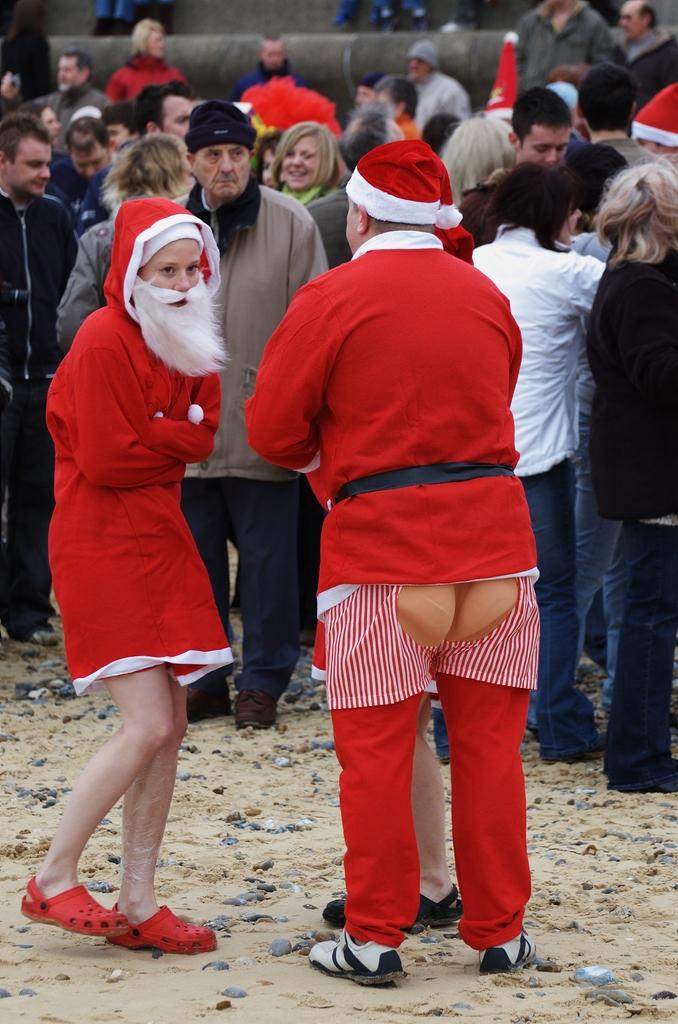How many people are dressed as Santa Claus in the image? There are three persons dressed as Santa Claus in the image. What can be seen in the background of the image? There is a group of people in the background of the image. What are some of the people in the background wearing? Some of the people in the background are wearing Santa Claus hats. What type of rake is being used by the Santa Claus in the image? There is no rake present in the image; the three persons are dressed as Santa Claus and there are no gardening tools visible. 